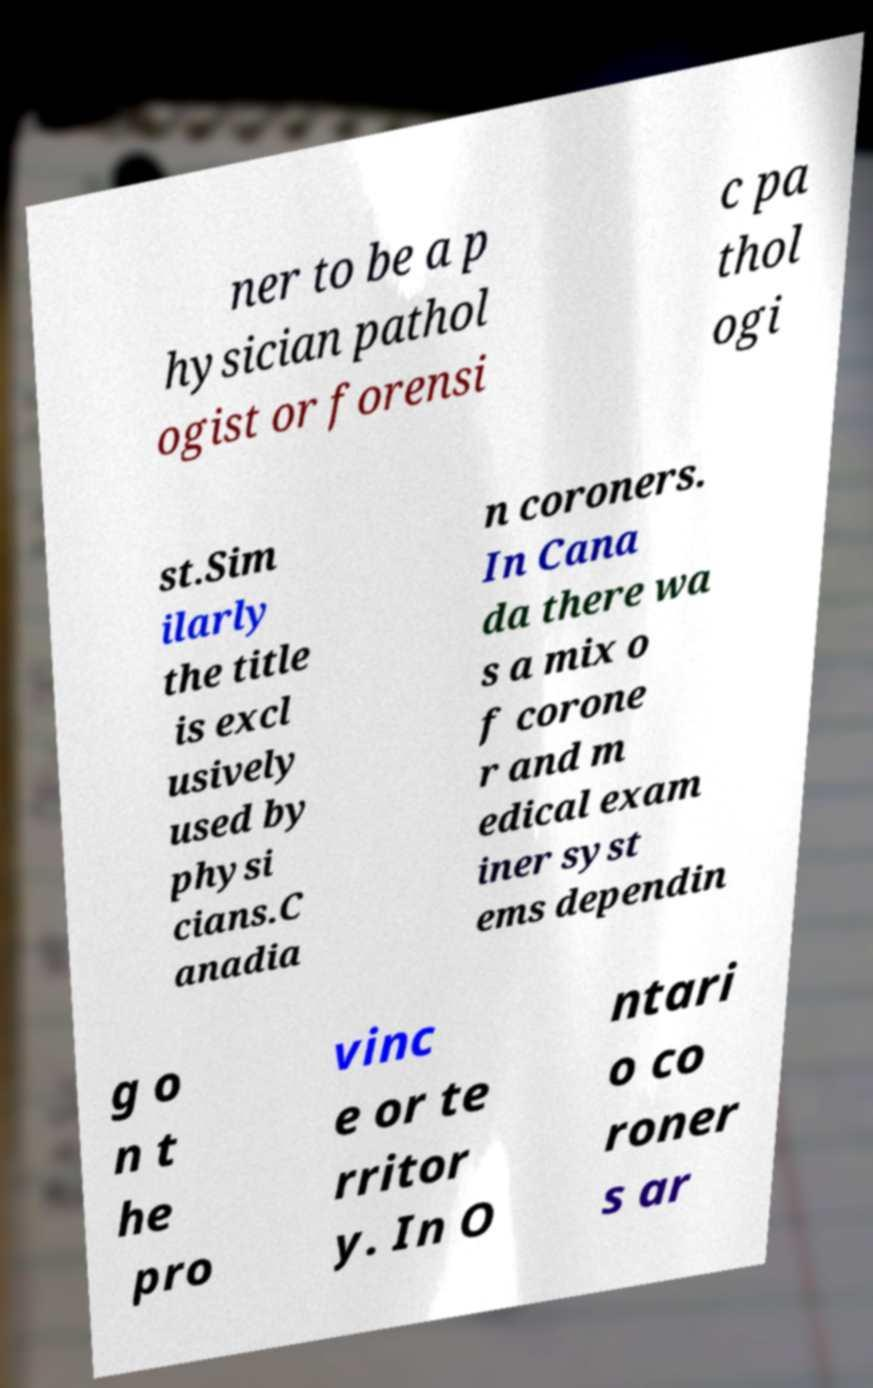There's text embedded in this image that I need extracted. Can you transcribe it verbatim? ner to be a p hysician pathol ogist or forensi c pa thol ogi st.Sim ilarly the title is excl usively used by physi cians.C anadia n coroners. In Cana da there wa s a mix o f corone r and m edical exam iner syst ems dependin g o n t he pro vinc e or te rritor y. In O ntari o co roner s ar 